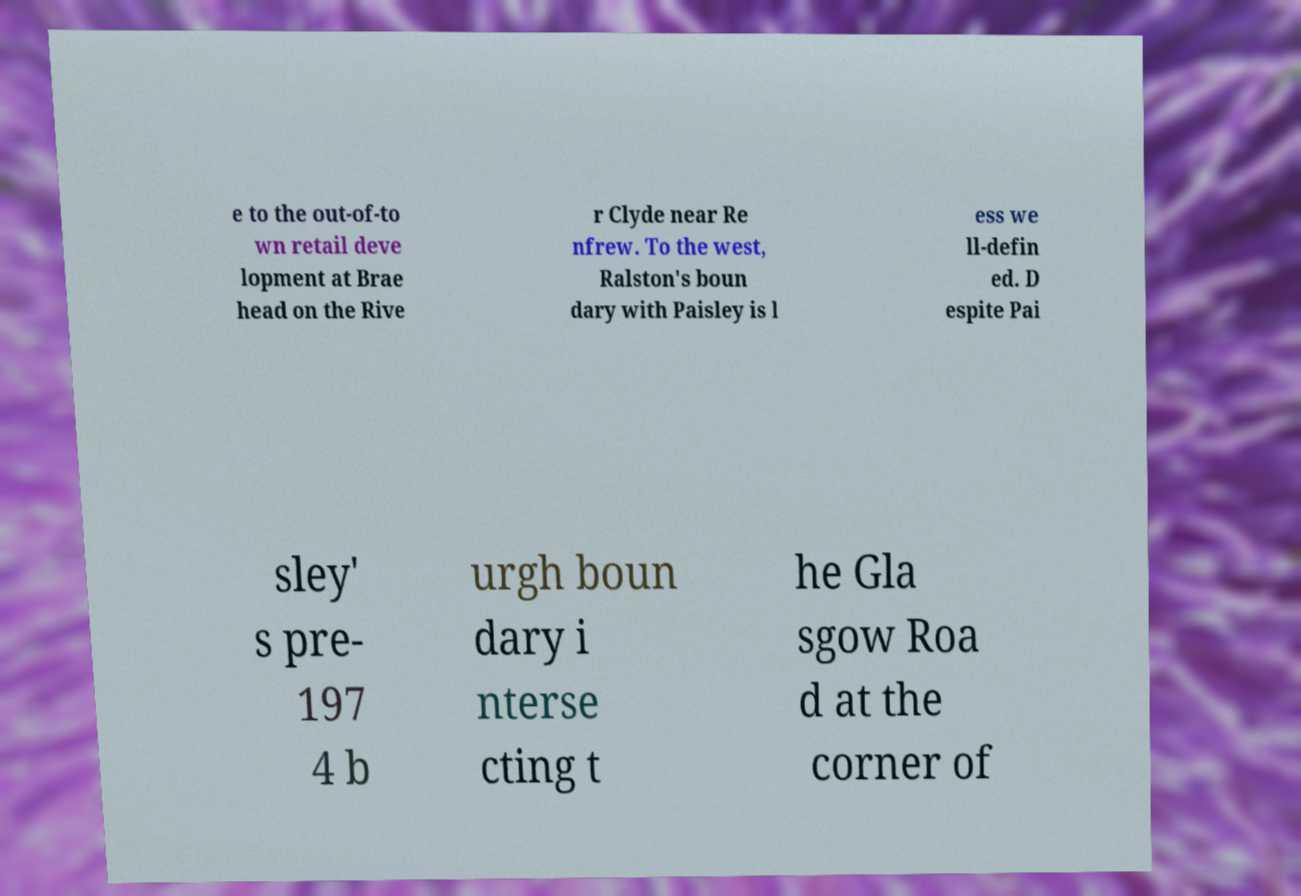There's text embedded in this image that I need extracted. Can you transcribe it verbatim? e to the out-of-to wn retail deve lopment at Brae head on the Rive r Clyde near Re nfrew. To the west, Ralston's boun dary with Paisley is l ess we ll-defin ed. D espite Pai sley' s pre- 197 4 b urgh boun dary i nterse cting t he Gla sgow Roa d at the corner of 